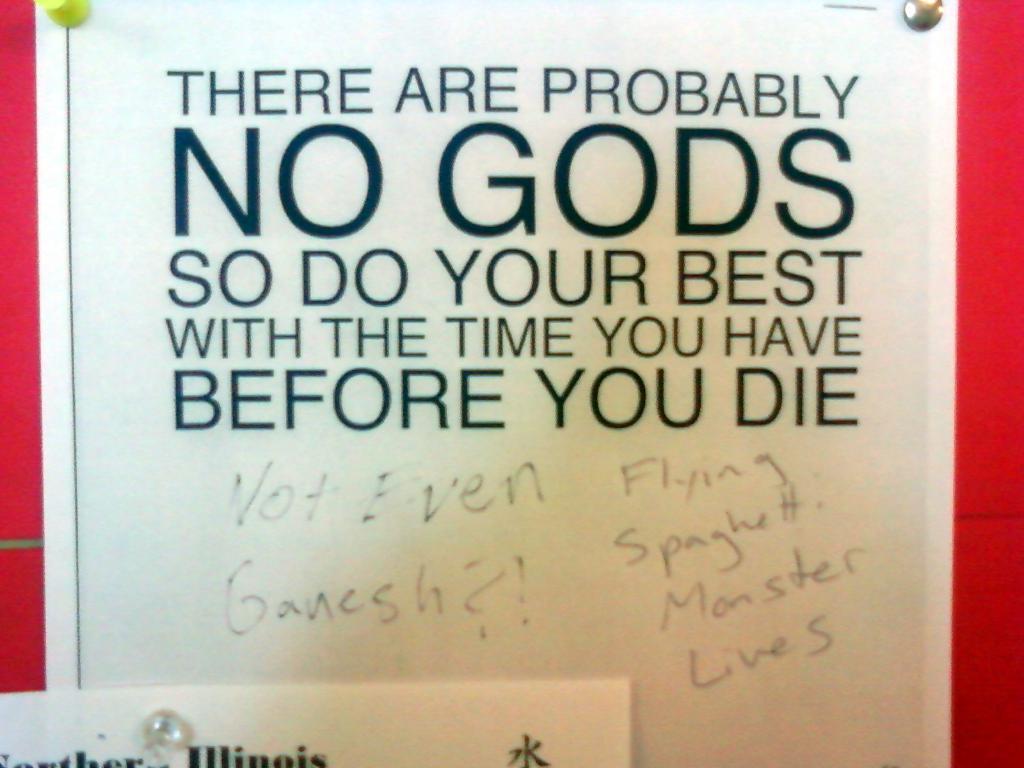Are there any gods?
Provide a succinct answer. No. What do you need to do before you die?
Provide a succinct answer. Do your best with the time you have. 